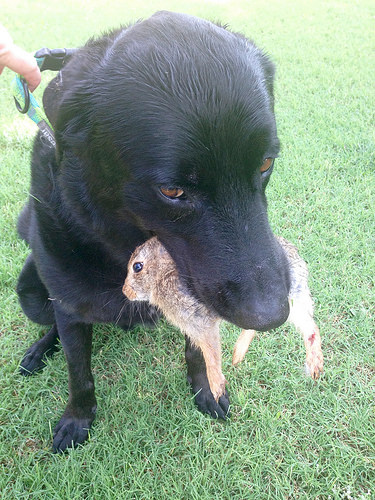<image>
Is the rabbit in the dog? Yes. The rabbit is contained within or inside the dog, showing a containment relationship. Where is the dog in relation to the rabbit? Is it in front of the rabbit? No. The dog is not in front of the rabbit. The spatial positioning shows a different relationship between these objects. 